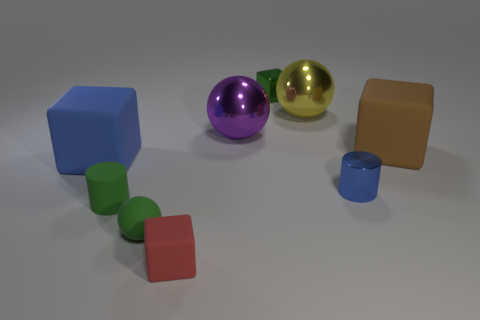Add 1 purple things. How many objects exist? 10 Subtract all balls. How many objects are left? 6 Subtract all small red matte blocks. Subtract all big purple objects. How many objects are left? 7 Add 8 green rubber objects. How many green rubber objects are left? 10 Add 9 brown things. How many brown things exist? 10 Subtract 0 yellow cubes. How many objects are left? 9 